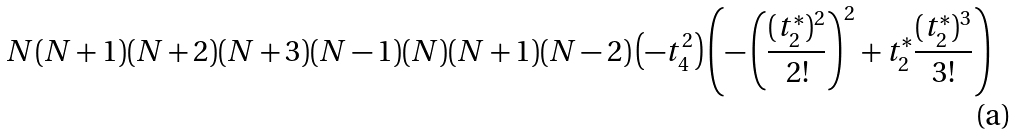<formula> <loc_0><loc_0><loc_500><loc_500>N ( N + 1 ) ( N + 2 ) ( N + 3 ) ( N - 1 ) ( N ) ( N + 1 ) ( N - 2 ) \left ( - t _ { 4 } ^ { 2 } \right ) \left ( - \left ( \frac { ( t _ { 2 } ^ { * } ) ^ { 2 } } { 2 ! } \right ) ^ { 2 } + t _ { 2 } ^ { * } \frac { ( t ^ { * } _ { 2 } ) ^ { 3 } } { 3 ! } \right )</formula> 